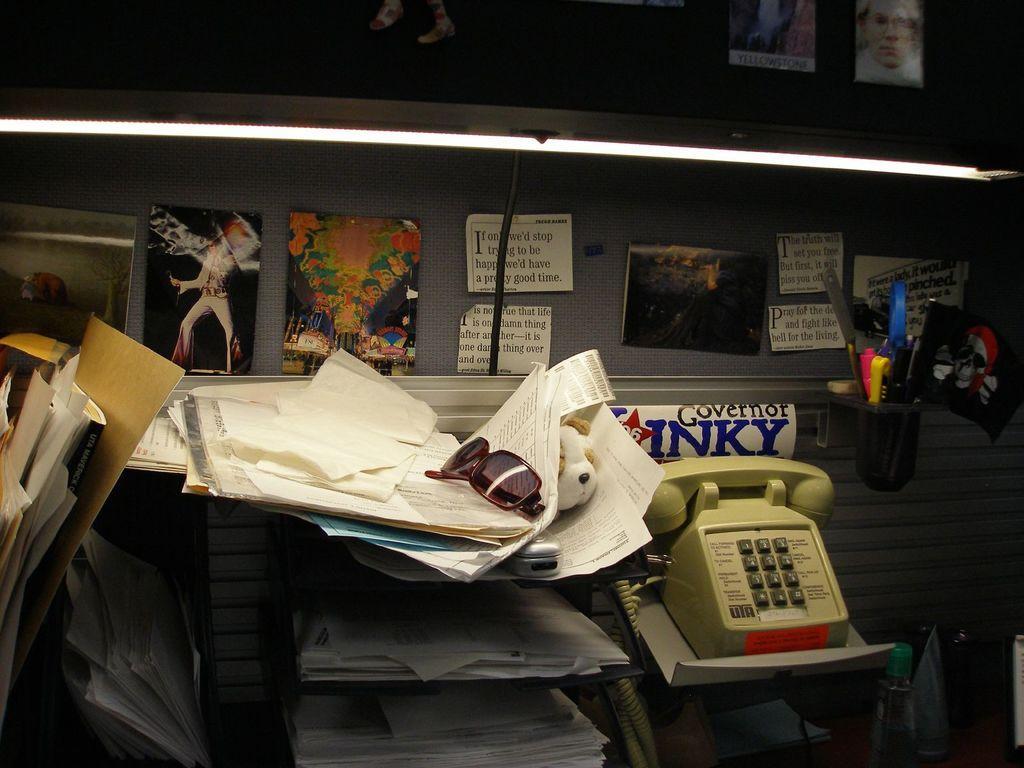How would you summarize this image in a sentence or two? On the right side it's a telephone, on the left side these are the papers. There are few photographs on this wall. 